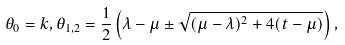Convert formula to latex. <formula><loc_0><loc_0><loc_500><loc_500>\theta _ { 0 } = k , \theta _ { 1 , 2 } = \frac { 1 } { 2 } \left ( \lambda - \mu \pm \sqrt { ( \mu - \lambda ) ^ { 2 } + 4 ( t - \mu ) } \right ) ,</formula> 